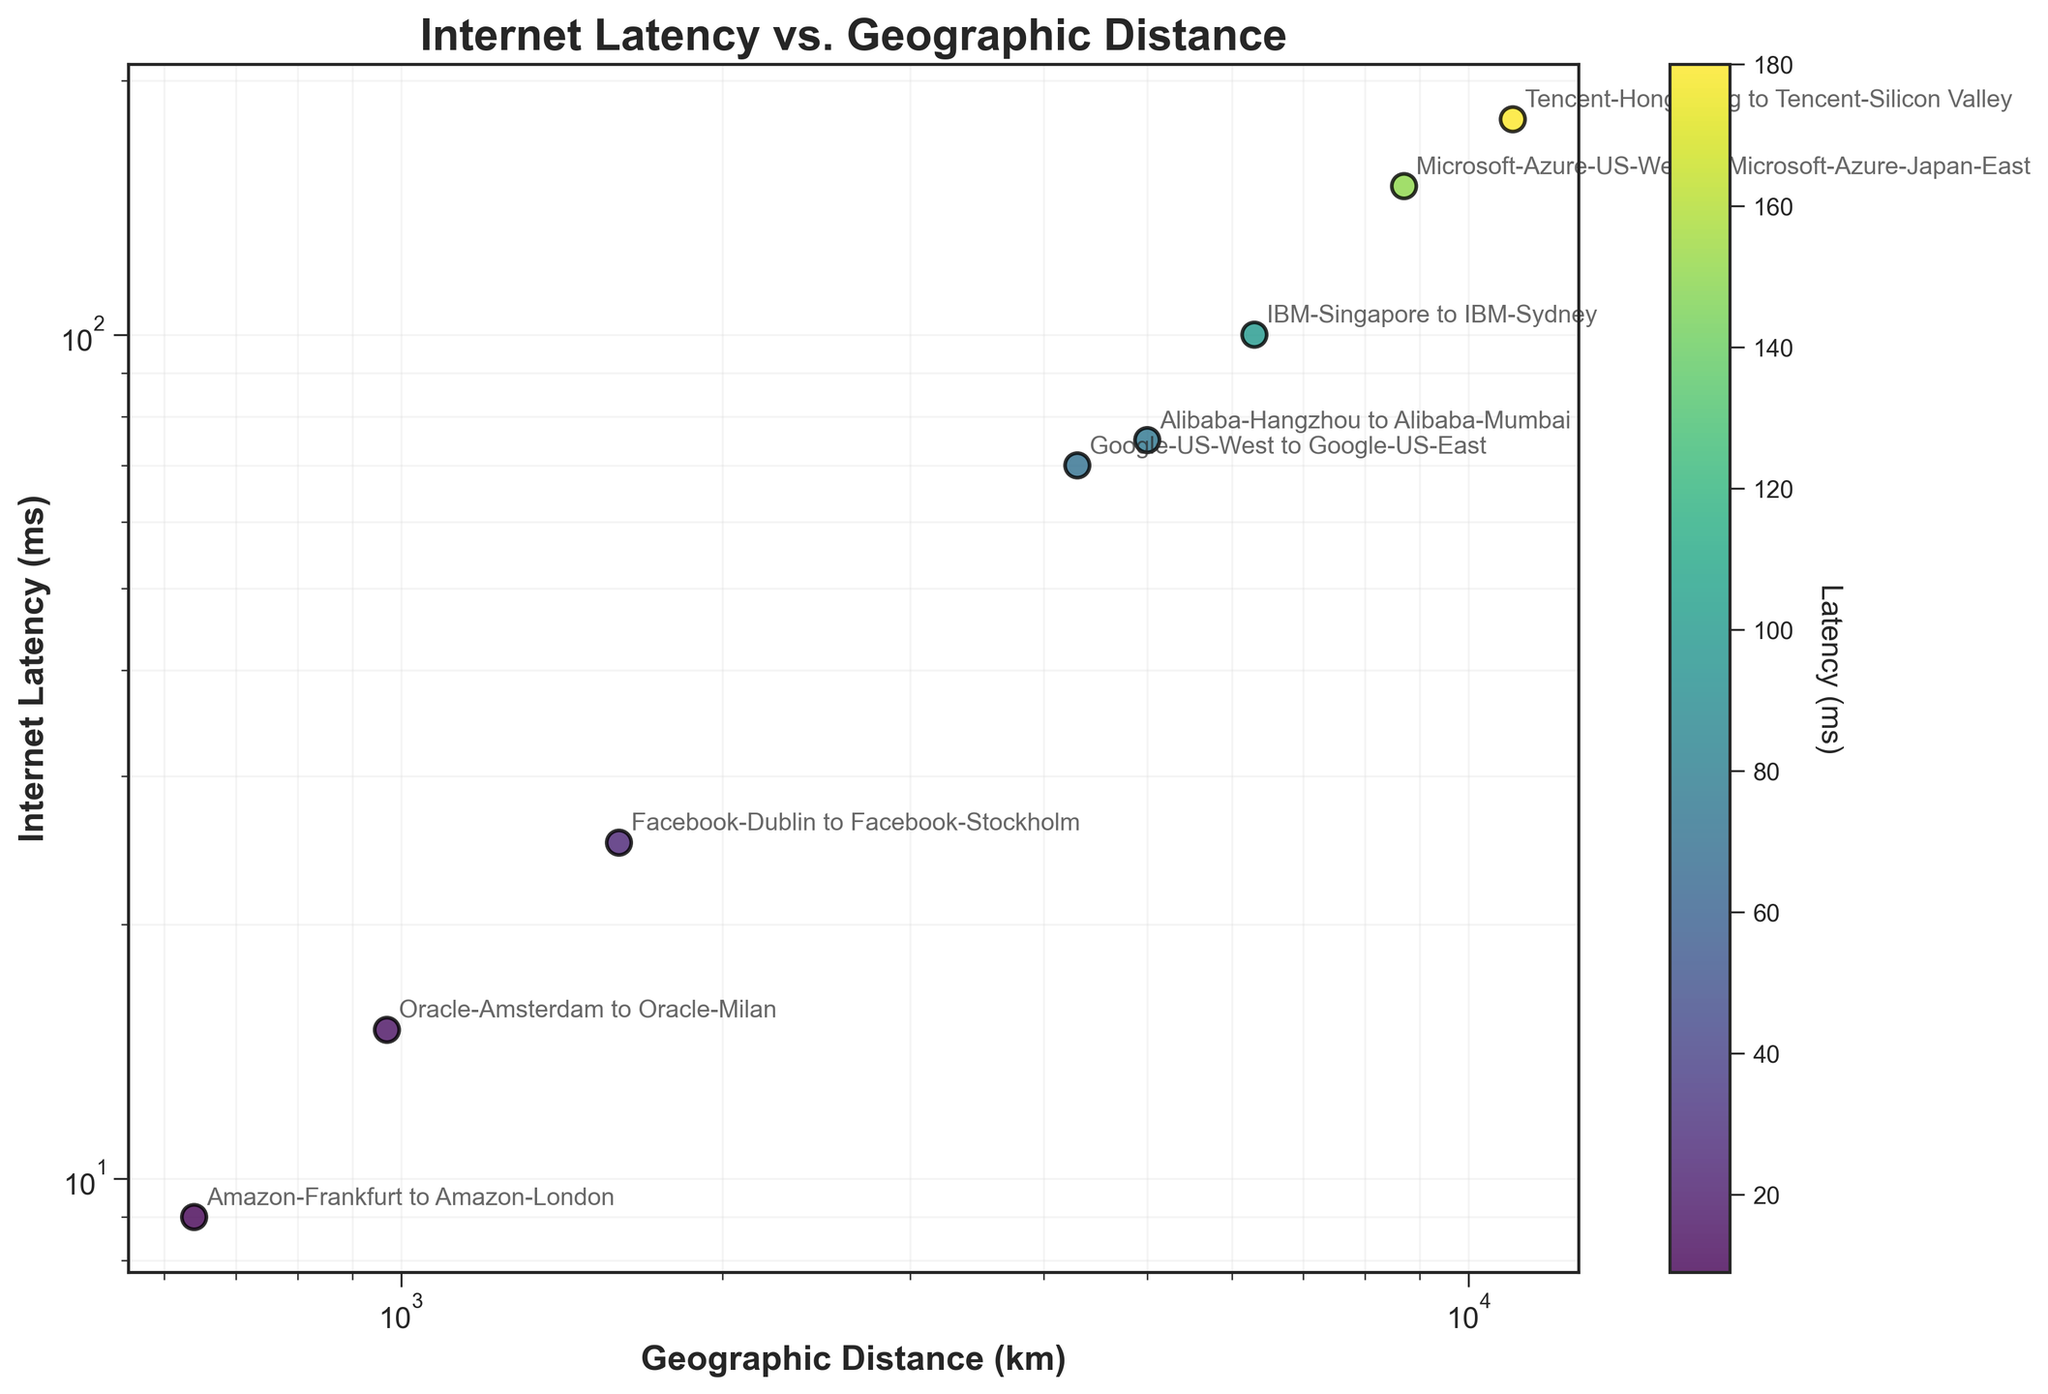What is the title of the plot? The title is displayed at the top of the plot, indicating the main subject matter. It reads "Internet Latency vs. Geographic Distance", which signifies the relationship being illustrated.
Answer: Internet Latency vs. Geographic Distance How many data points are plotted in the figure? Each data point represents a pair of data centers' geographic distance and internet latency. Counting them reveals that there are 8 data points in total.
Answer: 8 Which data center pair has the highest latency? By examining the y-axis values of the data points, the highest latency corresponds to the pair annotated with 'Tencent-Hong Kong to Tencent-Silicon Valley', which has a latency of 180 ms.
Answer: Tencent-Hong Kong to Tencent-Silicon Valley Which data center pair has the shortest geographic distance? By inspecting the x-axis values, the shortest distance corresponds to the pair 'Amazon-Frankfurt to Amazon-London', which has a geographic distance of 640 km.
Answer: Amazon-Frankfurt to Amazon-London What is the geographic distance and internet latency for the Facebook-Dublin to Facebook-Stockholm pair? Find the annotation 'Facebook-Dublin to Facebook-Stockholm' on the plot. The x-axis value at this point is 1600 km, and the y-axis value is 25 ms.
Answer: 1600 km, 25 ms Do greater geographic distances generally correlate with higher internet latencies in the plot? By observing the general trend of data points as they move rightward (increasing distance) on the x-axis, they tend to move upward (increasing latency) on the y-axis. This suggests a positive correlation.
Answer: Yes Which data center pair has the second highest internet latency? After identifying the highest latency pair ('Tencent-Hong Kong to Tencent-Silicon Valley' at 180 ms), the next highest is 'Microsoft-Azure-US-West to Microsoft-Azure-Japan-East' at 150 ms.
Answer: Microsoft-Azure-US-West to Microsoft-Azure-Japan-East Between Oracle-Amsterdam to Oracle-Milan and IBM-Singapore to IBM-Sydney, which pair has a larger geographic distance and higher internet latency? Comparing both pairs, 'Oracle-Amsterdam to Oracle-Milan' has a distance of 970 km and latency of 15 ms, while 'IBM-Singapore to IBM-Sydney' has a distance of 6300 km and latency of 100 ms. Therefore, the latter has both larger distance and higher latency.
Answer: IBM-Singapore to IBM-Sydney 